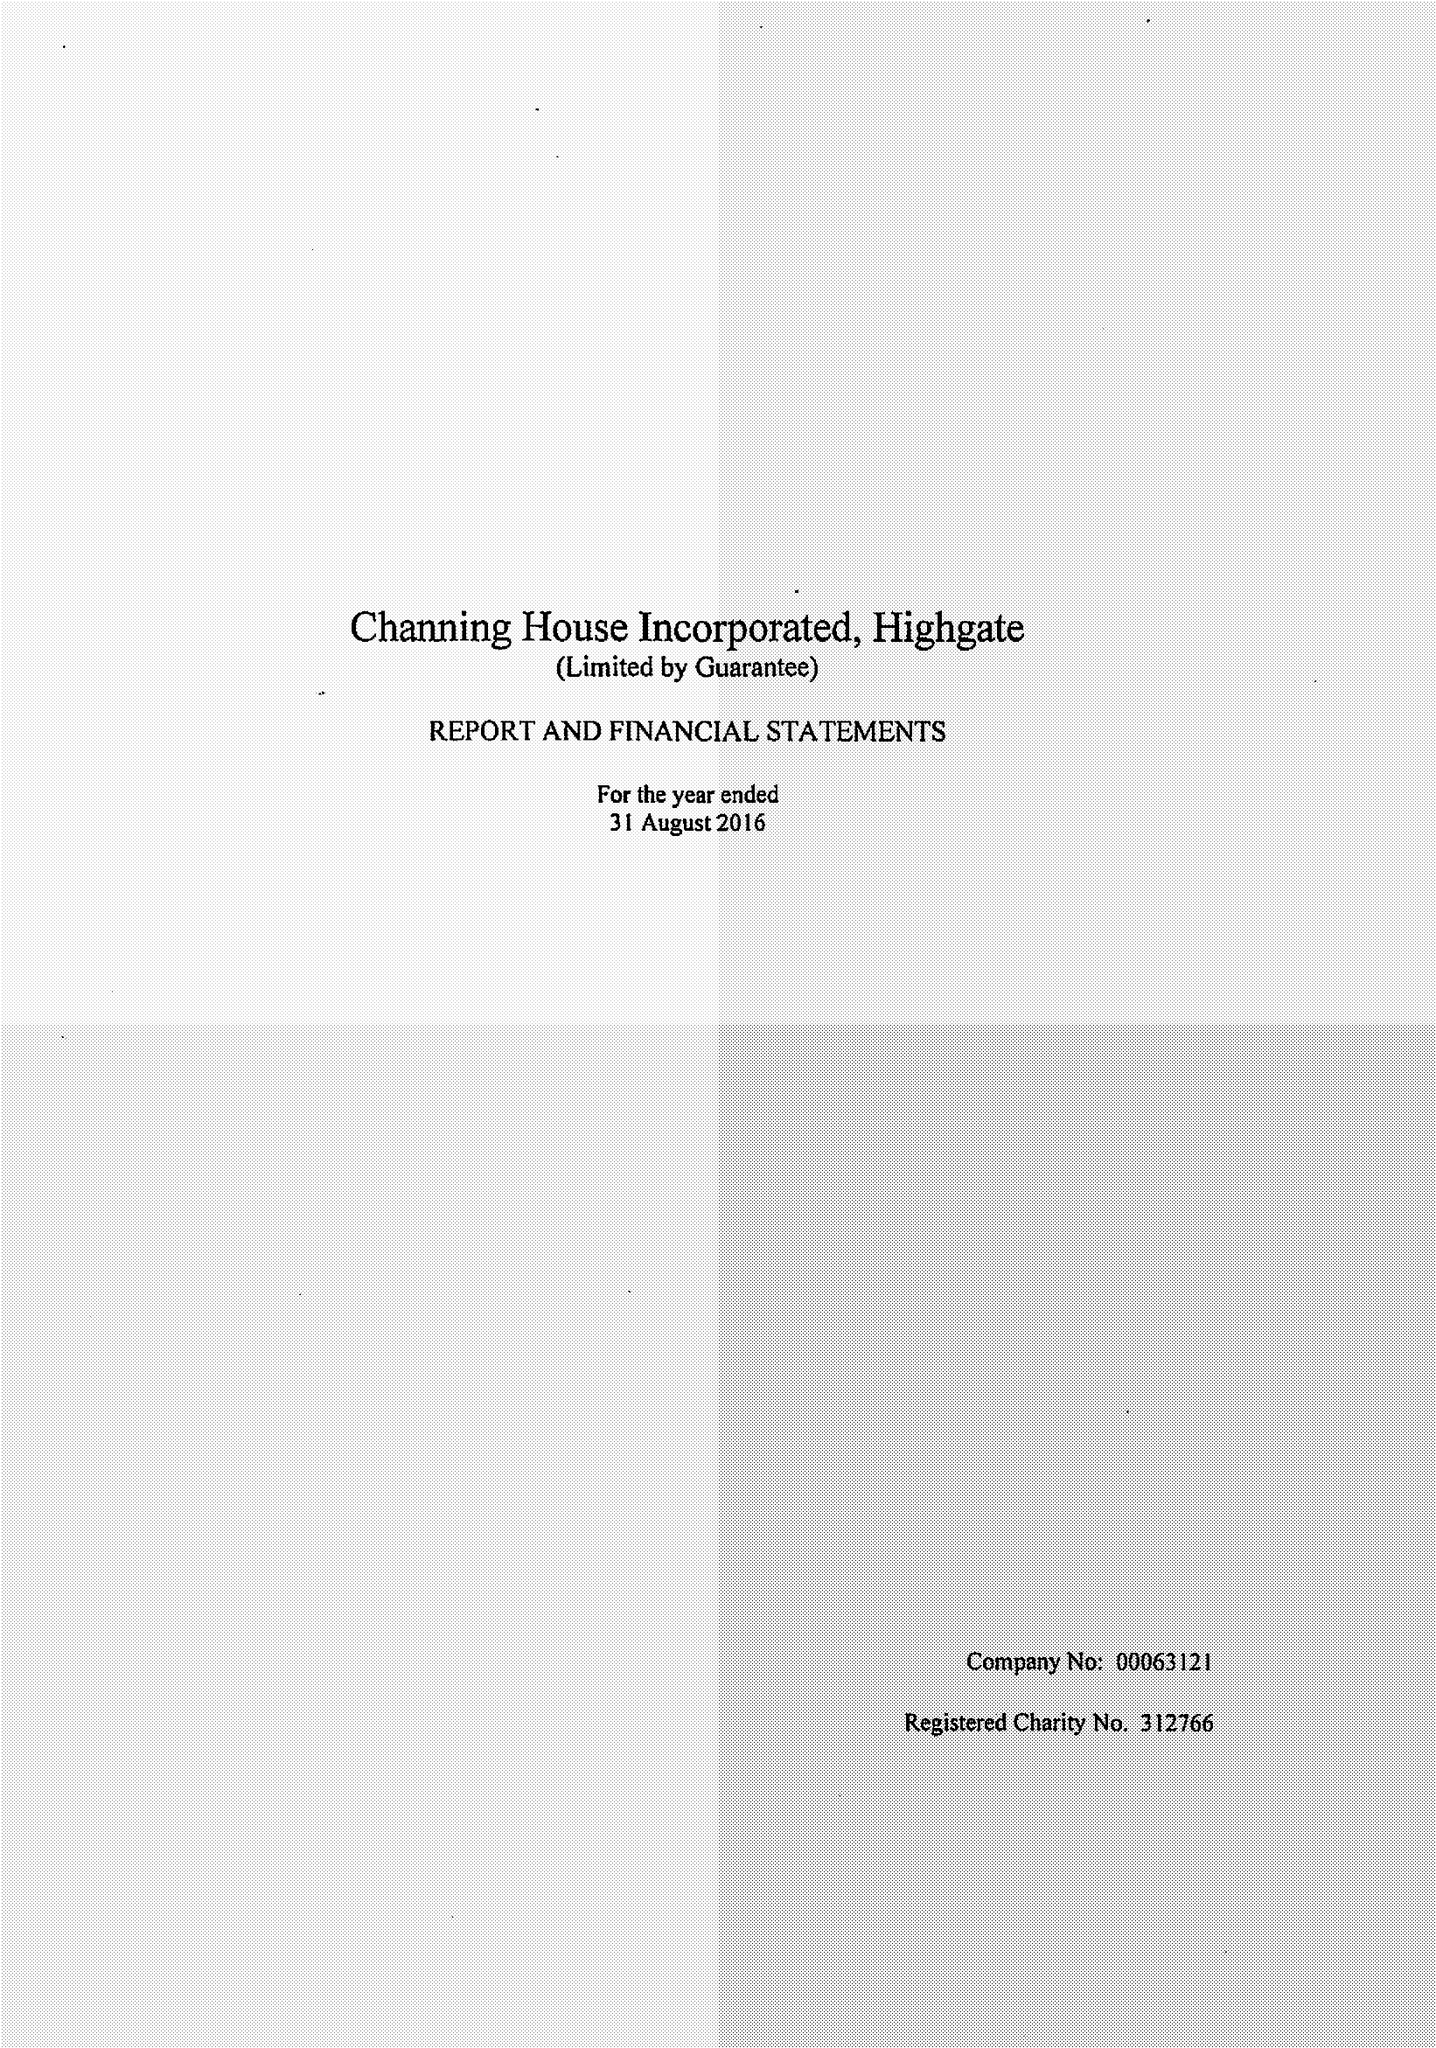What is the value for the report_date?
Answer the question using a single word or phrase. 2016-08-31 